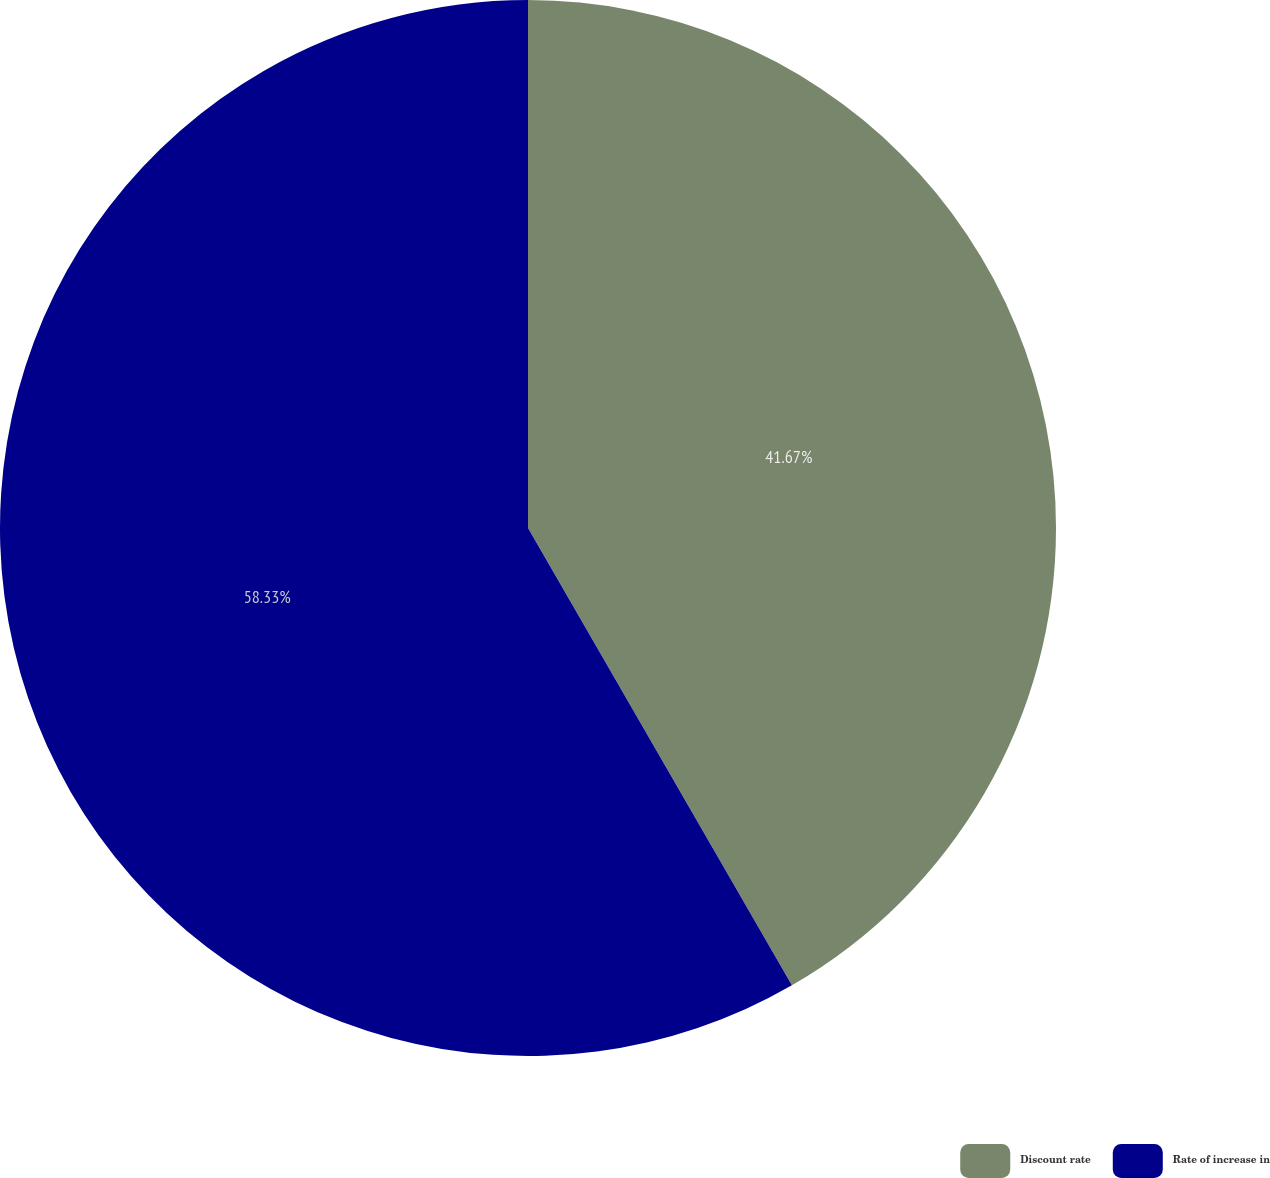Convert chart. <chart><loc_0><loc_0><loc_500><loc_500><pie_chart><fcel>Discount rate<fcel>Rate of increase in<nl><fcel>41.67%<fcel>58.33%<nl></chart> 